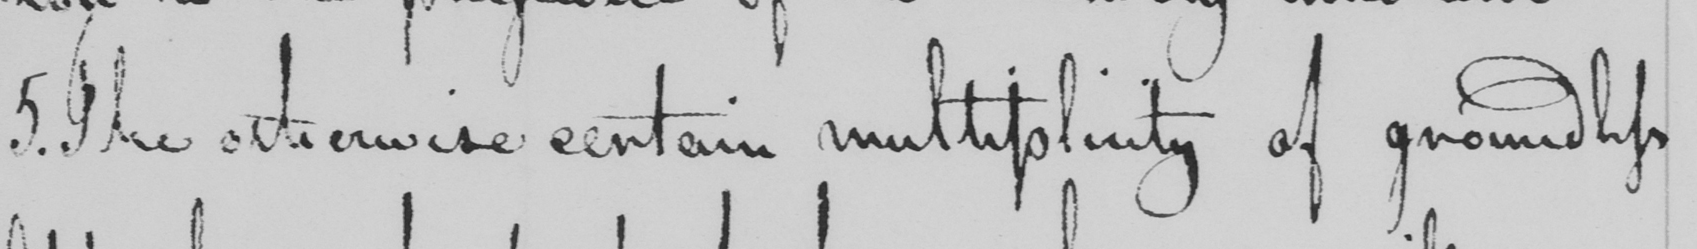What is written in this line of handwriting? 5 . The otherwise certain multiplicity of groundless 